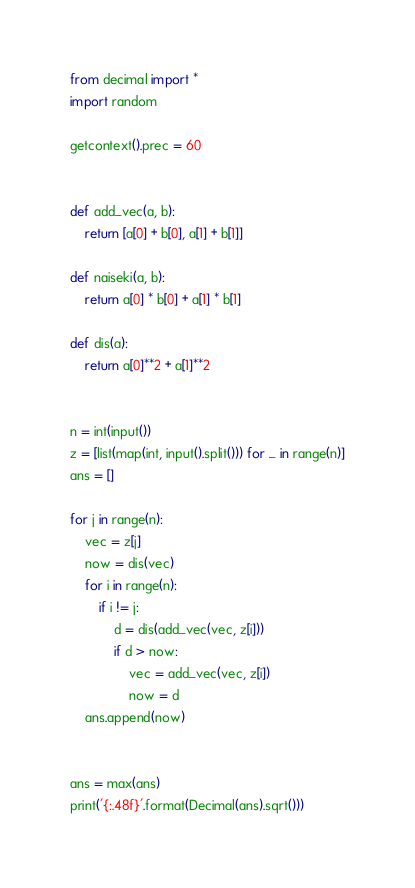Convert code to text. <code><loc_0><loc_0><loc_500><loc_500><_Python_>from decimal import *
import random

getcontext().prec = 60


def add_vec(a, b):
    return [a[0] + b[0], a[1] + b[1]]

def naiseki(a, b):
    return a[0] * b[0] + a[1] * b[1]

def dis(a):
    return a[0]**2 + a[1]**2


n = int(input())
z = [list(map(int, input().split())) for _ in range(n)]
ans = []

for j in range(n):
    vec = z[j]
    now = dis(vec)
    for i in range(n):
        if i != j:
            d = dis(add_vec(vec, z[i]))
            if d > now:
                vec = add_vec(vec, z[i])
                now = d
    ans.append(now)


ans = max(ans)
print('{:.48f}'.format(Decimal(ans).sqrt()))
</code> 